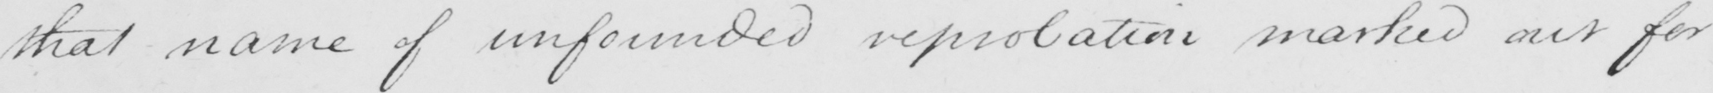Please provide the text content of this handwritten line. that name of unfounded reprobation marked out for 